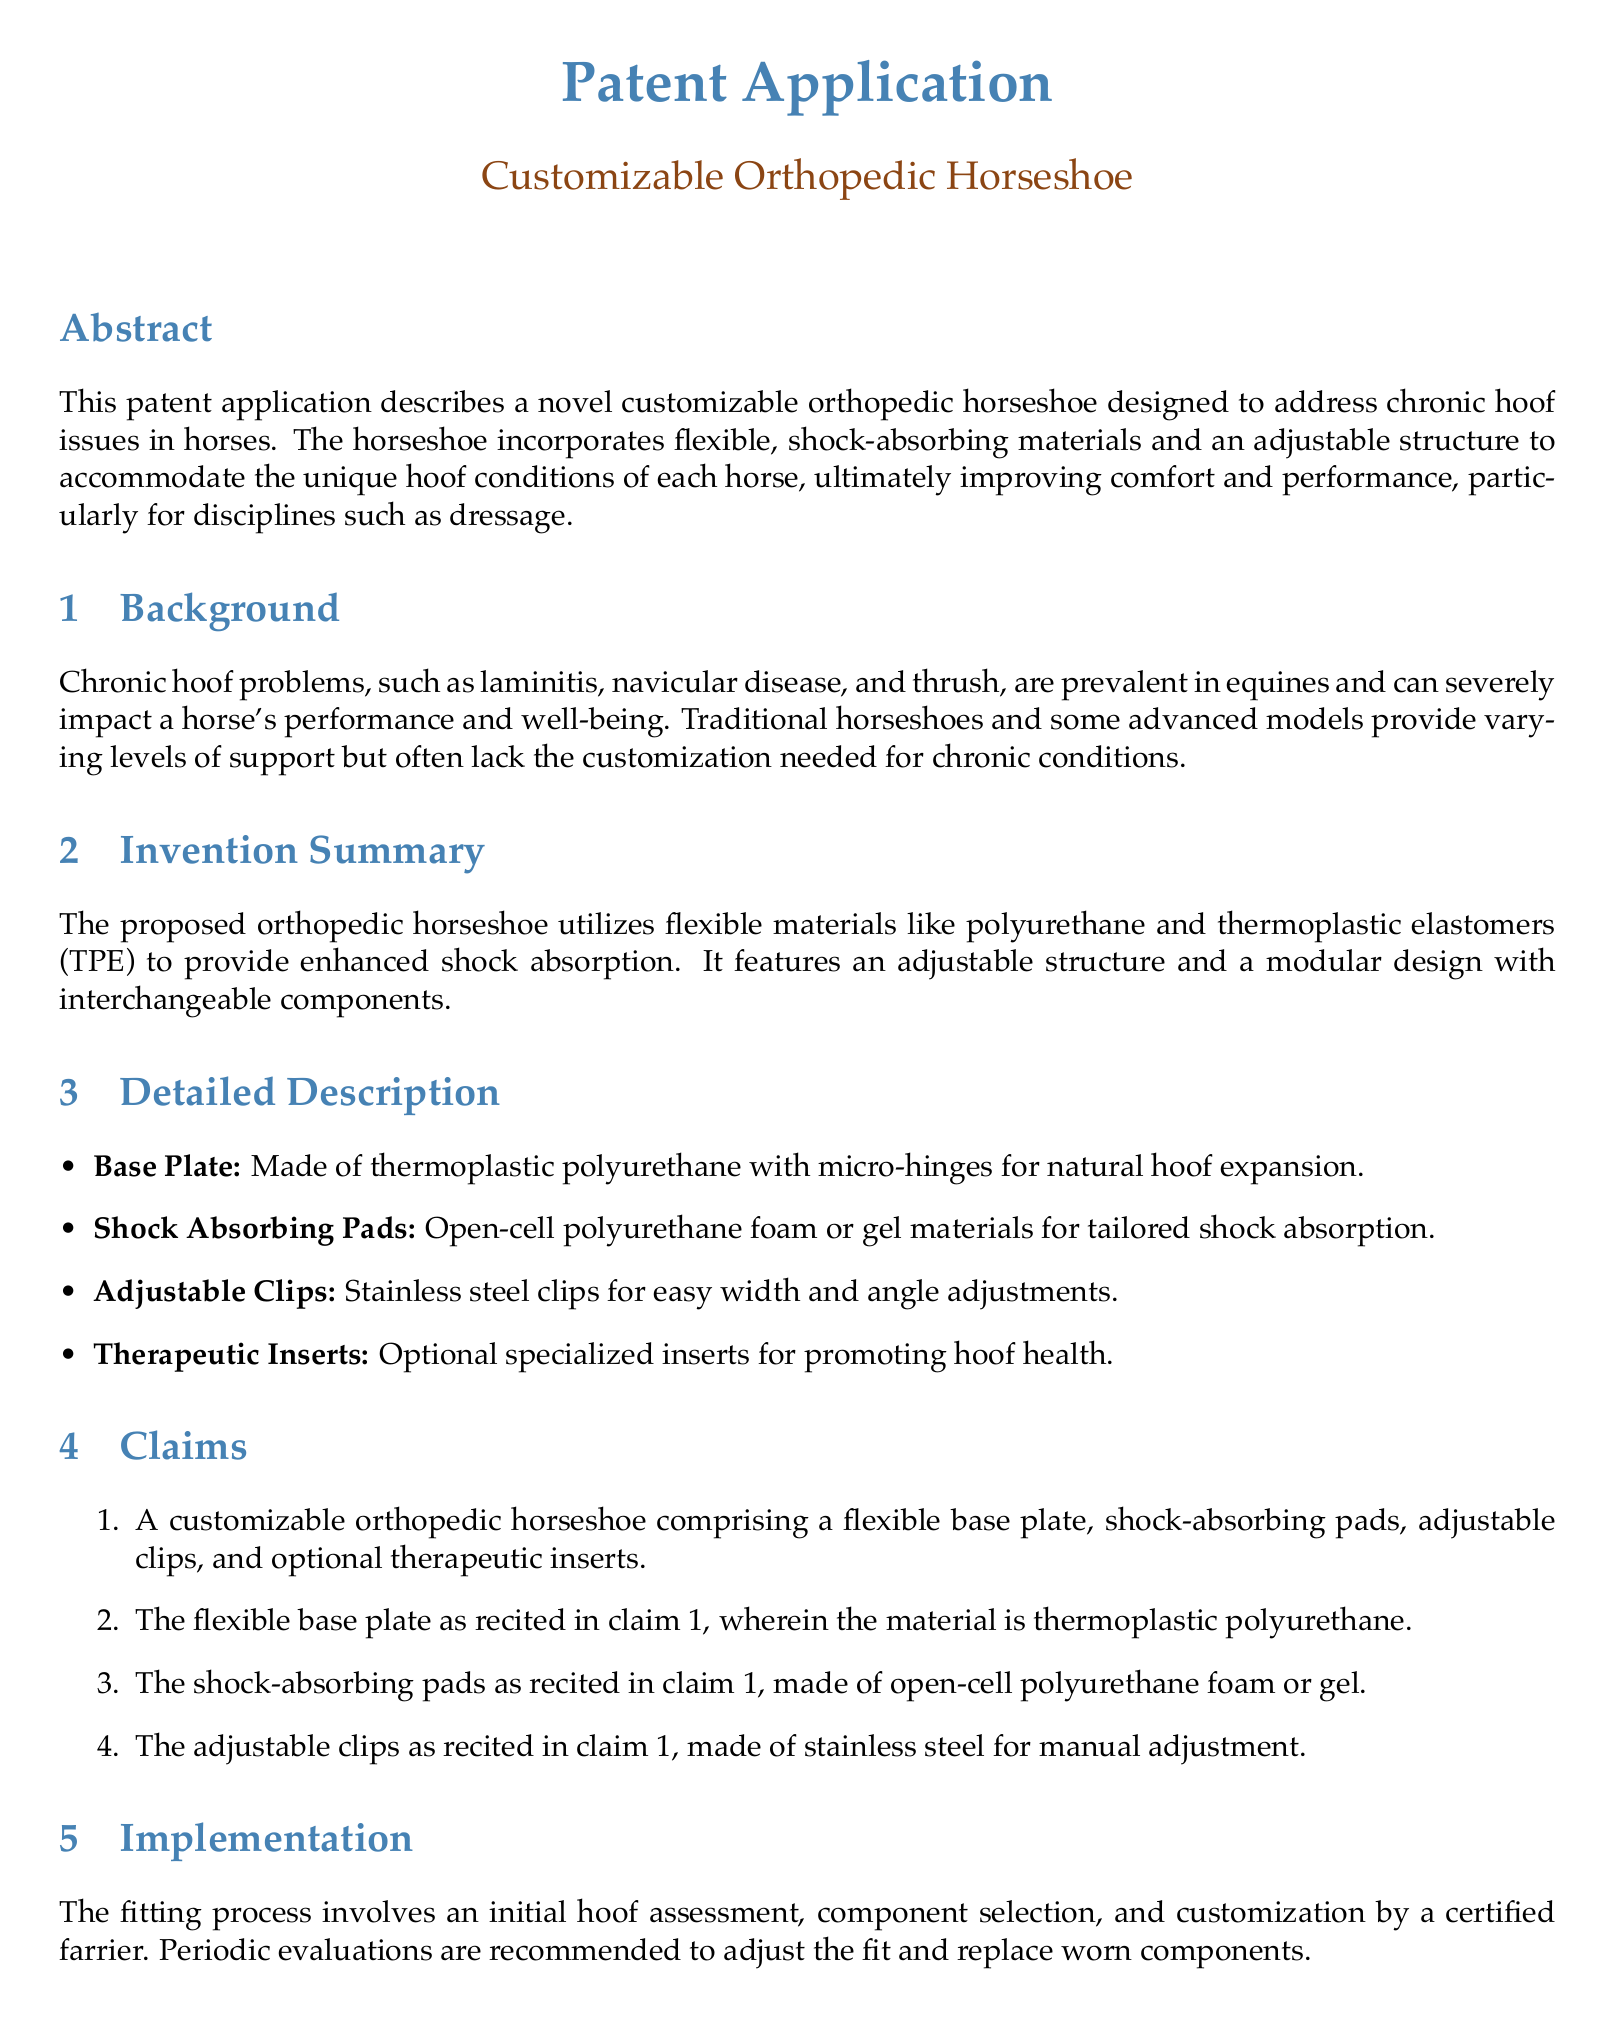what is the title of the patent application? The title is presented in the respective section of the document.
Answer: Customizable Orthopedic Horseshoe what materials are used for the base plate? The document specifies the material used for the base plate.
Answer: thermoplastic polyurethane what is one type of material used for shock-absorbing pads? The document lists the materials that can be used for shock-absorbing pads.
Answer: open-cell polyurethane foam how many claims are listed in the document? The number of claims is explicitly provided in the claims section.
Answer: four what is the purpose of the therapeutic inserts? The therapeutic inserts are mentioned in the detailed description section's context.
Answer: promoting hoof health who performs the fitting process? The document specifies who is responsible for the fitting process.
Answer: certified farrier what problem do chronic hoof problems affect? The document discusses issues caused by chronic hoof problems.
Answer: performance and well-being which disciplines benefit from the customizable horseshoe? The document identifies specific equestrian disciplines impacted.
Answer: dressage 